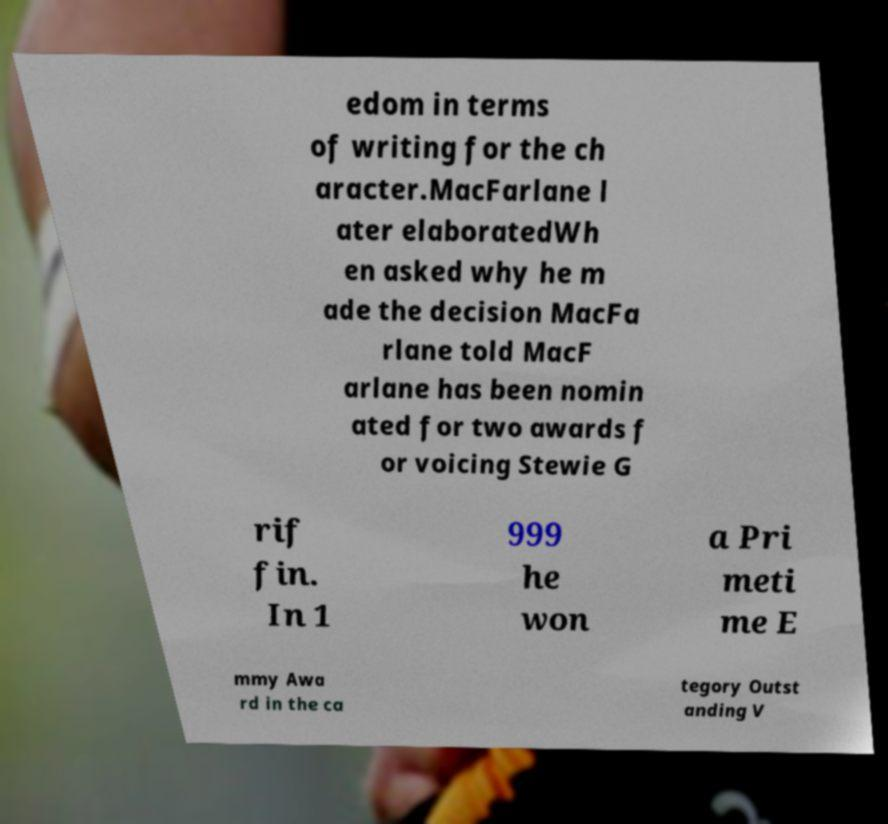Can you read and provide the text displayed in the image?This photo seems to have some interesting text. Can you extract and type it out for me? edom in terms of writing for the ch aracter.MacFarlane l ater elaboratedWh en asked why he m ade the decision MacFa rlane told MacF arlane has been nomin ated for two awards f or voicing Stewie G rif fin. In 1 999 he won a Pri meti me E mmy Awa rd in the ca tegory Outst anding V 